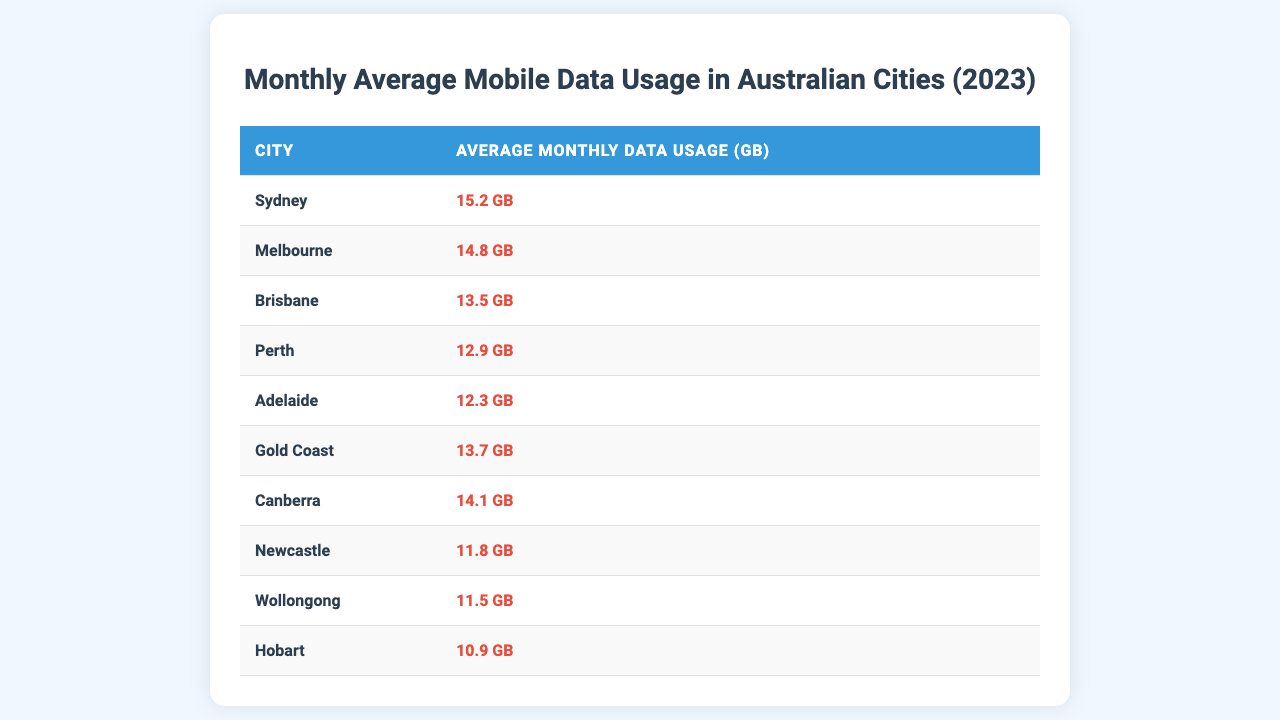What is the average monthly data usage in Sydney? The table shows Sydney's average monthly data usage is listed as 15.2 GB.
Answer: 15.2 GB Which city has the lowest average monthly data usage? By examining the table, Hobart has the lowest average monthly data usage at 10.9 GB.
Answer: Hobart What is the average monthly data usage for the cities of Adelaide and Perth? To find the average for Adelaide (12.3 GB) and Perth (12.9 GB), you add them: 12.3 + 12.9 = 25.2 GB, then divide by 2: 25.2 / 2 = 12.6 GB.
Answer: 12.6 GB Is Melbourne's average monthly data usage higher than Brisbane's? The table indicates Melbourne has 14.8 GB while Brisbane has 13.5 GB, so yes, Melbourne's usage is higher.
Answer: Yes Which city has a higher average monthly data usage: Brisbane or Gold Coast? Comparing the data, Brisbane has 13.5 GB while Gold Coast has 13.7 GB, meaning Gold Coast has a higher usage.
Answer: Gold Coast What is the difference in average monthly data usage between Adelaide and Canberra? Adelaide's usage is 12.3 GB and Canberra's is 14.1 GB. The difference is calculated as 14.1 - 12.3 = 1.8 GB.
Answer: 1.8 GB What are the average monthly data usages of the three cities with the highest usage? The top three cities are Sydney (15.2 GB), Melbourne (14.8 GB), and Canberra (14.1 GB). Adding these gives 15.2 + 14.8 + 14.1 = 44.1 GB. To find the average, divide by 3: 44.1 / 3 = 14.7 GB.
Answer: 14.7 GB Are there any cities that have the same average monthly data usage? No, each city listed has a different average monthly usage based on the data provided in the table.
Answer: No Which city has an average monthly data usage of 14.1 GB? The table lists Canberra as having an average monthly data usage of 14.1 GB.
Answer: Canberra What is the average monthly data usage of all ten cities listed? Summing all data usages (15.2 + 14.8 + 13.5 + 12.9 + 12.3 + 13.7 + 14.1 + 11.8 + 11.5 + 10.9) gives  14.1 average/10 cities = 13.52 GB (rounding may be applied in average for quick reference).
Answer: 13.52 GB 